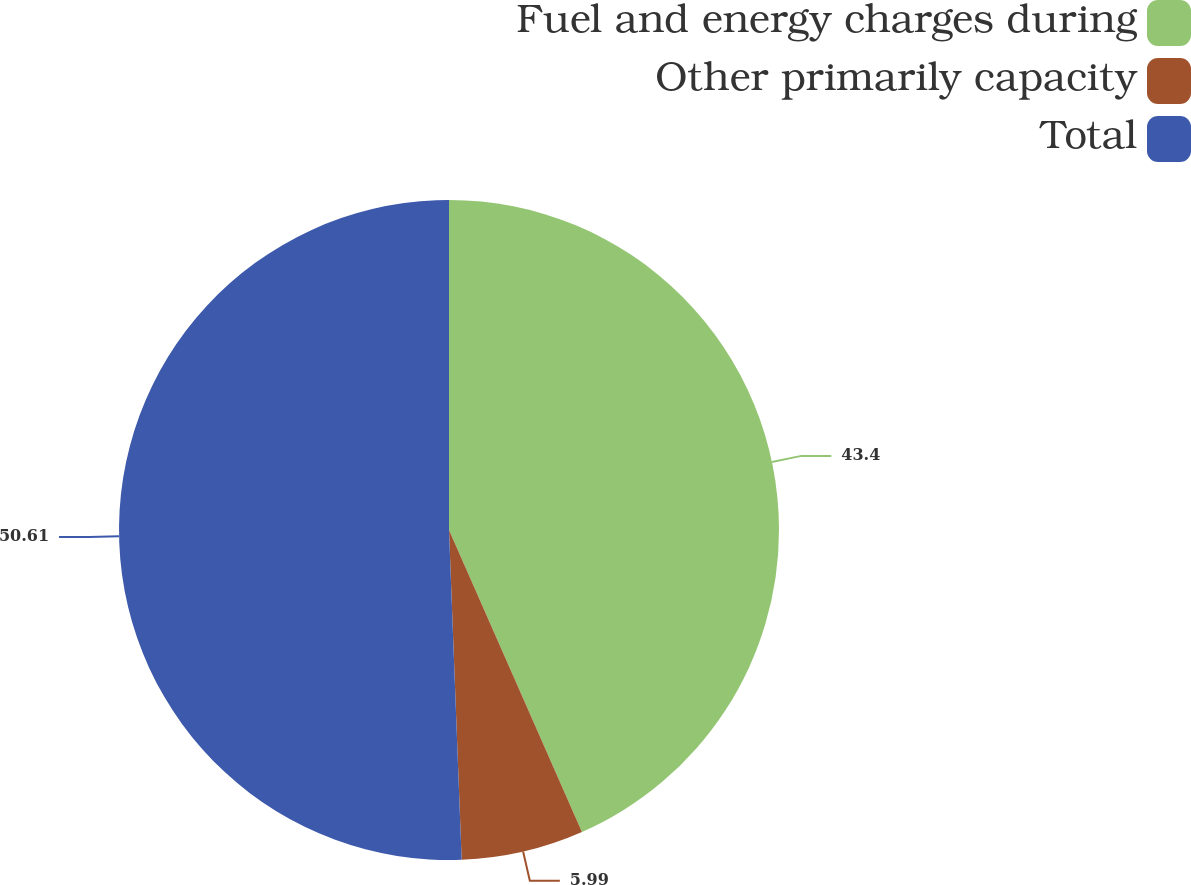Convert chart to OTSL. <chart><loc_0><loc_0><loc_500><loc_500><pie_chart><fcel>Fuel and energy charges during<fcel>Other primarily capacity<fcel>Total<nl><fcel>43.4%<fcel>5.99%<fcel>50.61%<nl></chart> 